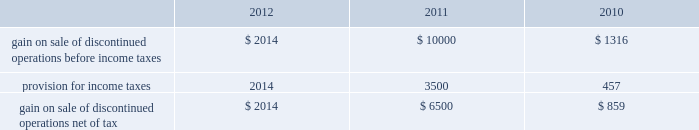Analog devices , inc .
Notes to consolidated financial statements 2014 ( continued ) asu no .
2011-05 is effective for fiscal years , and interim periods within those years , beginning after december 15 , 2011 , which is the company 2019s fiscal year 2013 .
Subsequently , in december 2011 , the fasb issued asu no .
2011-12 , deferral of the effective date for amendments to the presentation of reclassifications of items out of accumulated other comprehensive income in accounting standards update no .
2011-05 ( asu no .
2011-12 ) , which defers only those changes in asu no .
2011-05 that relate to the presentation of reclassification adjustments but does not affect all other requirements in asu no .
2011-05 .
The adoption of asu no .
2011-05 and asu no .
2011-12 will affect the presentation of comprehensive income but will not materially impact the company 2019s financial condition or results of operations .
Discontinued operations in november 2007 , the company entered into a purchase and sale agreement with certain subsidiaries of on semiconductor corporation to sell the company 2019s cpu voltage regulation and pc thermal monitoring business which consisted of core voltage regulator products for the central processing unit in computing and gaming applications and temperature sensors and fan-speed controllers for managing the temperature of the central processing unit .
During fiscal 2008 , the company completed the sale of this business .
In the first quarter of fiscal 2010 , proceeds of $ 1 million were released from escrow and $ 0.6 million net of tax was recorded as additional gain from the sale of discontinued operations .
The company does not expect any additional proceeds from this sale .
In september 2007 , the company entered into a definitive agreement to sell its baseband chipset business to mediatek inc .
The decision to sell the baseband chipset business was due to the company 2019s decision to focus its resources in areas where its signal processing expertise can provide unique capabilities and earn superior returns .
During fiscal 2008 , the company completed the sale of its baseband chipset business for net cash proceeds of $ 269 million .
The company made cash payments of $ 1.7 million during fiscal 2009 related to retention payments for employees who transferred to mediatek inc .
And for the reimbursement of intellectual property license fees incurred by mediatek .
During fiscal 2010 , the company received cash proceeds of $ 62 million as a result of the receipt of a refundable withholding tax and also recorded an additional gain on sale of $ 0.3 million , or $ 0.2 million net of tax , due to the settlement of certain items at less than the amounts accrued .
In fiscal 2011 , additional proceeds of $ 10 million were released from escrow and $ 6.5 million net of tax was recorded as additional gain from the sale of discontinued operations .
The company does not expect any additional proceeds from this sale .
The following amounts related to the cpu voltage regulation and pc thermal monitoring and baseband chipset businesses have been segregated from continuing operations and reported as discontinued operations. .
Stock-based compensation and shareholders 2019 equity equity compensation plans the company grants , or has granted , stock options and other stock and stock-based awards under the 2006 stock incentive plan ( 2006 plan ) .
The 2006 plan was approved by the company 2019s board of directors on january 23 , 2006 and was approved by shareholders on march 14 , 2006 and subsequently amended in march 2006 , june 2009 , september 2009 , december 2009 , december 2010 and june 2011 .
The 2006 plan provides for the grant of up to 15 million shares of the company 2019s common stock , plus such number of additional shares that were subject to outstanding options under the company 2019s previous plans that are not issued because the applicable option award subsequently terminates or expires without being exercised .
The 2006 plan provides for the grant of incentive stock options intended to qualify under section 422 of the internal revenue code of 1986 , as amended , non-statutory stock options , stock appreciation rights , restricted stock , restricted stock units and other stock-based awards .
Employees , officers , directors , consultants and advisors of the company and its subsidiaries are eligible to be granted awards under the 2006 plan .
No award may be made under the 2006 plan after march 13 , 2016 , but awards previously granted may extend beyond that date .
The company will not grant further options under any previous plans .
While the company may grant to employees options that become exercisable at different times or within different periods , the company has generally granted to employees options that vest over five years and become exercisable in annual installments of 20% ( 20 % ) on each of the first , second , third , fourth and fifth anniversaries of the date of grant ; 33.3% ( 33.3 % ) on each of the third , fourth , and fifth anniversaries of the date of grant ; or in annual installments of 25% ( 25 % ) on each of the second , third , fourth .
For the years of 2011 and 2010 , what percentage of the gain on sale went towards income tax? 
Rationale: to find the income tax one must divide the amount taken from the income tax by the initial amount before income tax .
Computations: (457 / 1316)
Answer: 0.34726. 